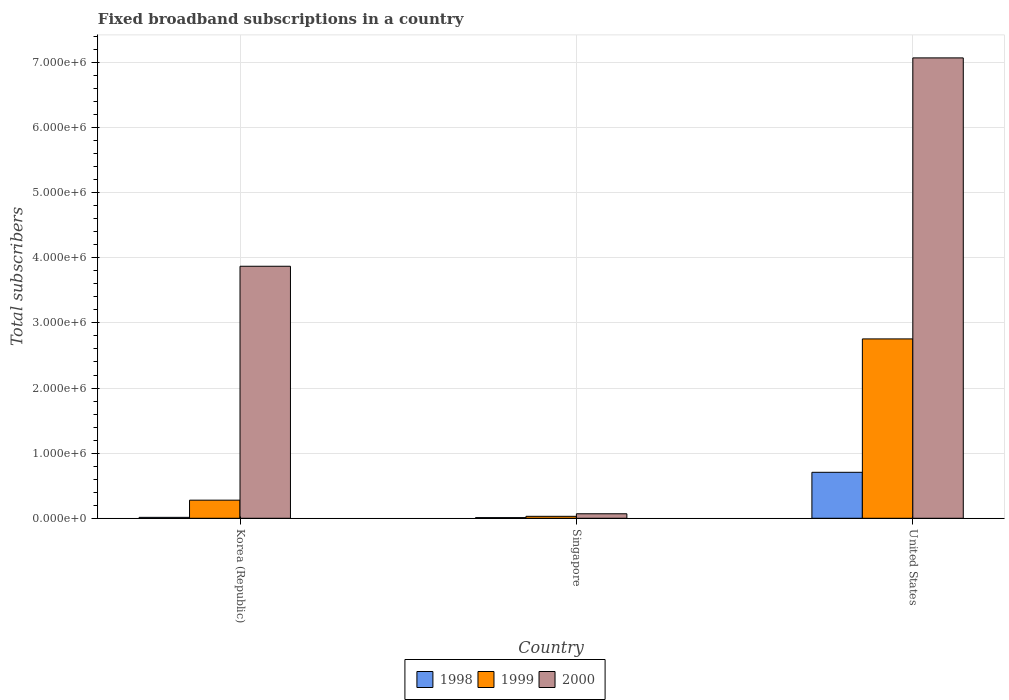How many groups of bars are there?
Offer a terse response. 3. Are the number of bars per tick equal to the number of legend labels?
Ensure brevity in your answer.  Yes. What is the label of the 2nd group of bars from the left?
Provide a short and direct response. Singapore. In how many cases, is the number of bars for a given country not equal to the number of legend labels?
Keep it short and to the point. 0. What is the number of broadband subscriptions in 2000 in United States?
Give a very brief answer. 7.07e+06. Across all countries, what is the maximum number of broadband subscriptions in 1998?
Your response must be concise. 7.06e+05. In which country was the number of broadband subscriptions in 1999 minimum?
Your response must be concise. Singapore. What is the total number of broadband subscriptions in 1998 in the graph?
Provide a short and direct response. 7.30e+05. What is the difference between the number of broadband subscriptions in 2000 in Korea (Republic) and that in United States?
Offer a very short reply. -3.20e+06. What is the difference between the number of broadband subscriptions in 2000 in Singapore and the number of broadband subscriptions in 1998 in United States?
Provide a succinct answer. -6.37e+05. What is the average number of broadband subscriptions in 1999 per country?
Make the answer very short. 1.02e+06. What is the difference between the number of broadband subscriptions of/in 2000 and number of broadband subscriptions of/in 1999 in Singapore?
Give a very brief answer. 3.90e+04. In how many countries, is the number of broadband subscriptions in 2000 greater than 7200000?
Keep it short and to the point. 0. What is the ratio of the number of broadband subscriptions in 1999 in Singapore to that in United States?
Your answer should be compact. 0.01. Is the number of broadband subscriptions in 1998 in Singapore less than that in United States?
Provide a succinct answer. Yes. What is the difference between the highest and the second highest number of broadband subscriptions in 1999?
Offer a terse response. 2.48e+05. What is the difference between the highest and the lowest number of broadband subscriptions in 2000?
Offer a terse response. 7.00e+06. In how many countries, is the number of broadband subscriptions in 2000 greater than the average number of broadband subscriptions in 2000 taken over all countries?
Provide a short and direct response. 2. How many bars are there?
Provide a short and direct response. 9. How many countries are there in the graph?
Your answer should be very brief. 3. Does the graph contain grids?
Keep it short and to the point. Yes. Where does the legend appear in the graph?
Make the answer very short. Bottom center. What is the title of the graph?
Offer a terse response. Fixed broadband subscriptions in a country. What is the label or title of the Y-axis?
Give a very brief answer. Total subscribers. What is the Total subscribers of 1998 in Korea (Republic)?
Keep it short and to the point. 1.40e+04. What is the Total subscribers of 1999 in Korea (Republic)?
Offer a very short reply. 2.78e+05. What is the Total subscribers in 2000 in Korea (Republic)?
Your answer should be compact. 3.87e+06. What is the Total subscribers in 1999 in Singapore?
Ensure brevity in your answer.  3.00e+04. What is the Total subscribers of 2000 in Singapore?
Make the answer very short. 6.90e+04. What is the Total subscribers of 1998 in United States?
Make the answer very short. 7.06e+05. What is the Total subscribers of 1999 in United States?
Ensure brevity in your answer.  2.75e+06. What is the Total subscribers in 2000 in United States?
Make the answer very short. 7.07e+06. Across all countries, what is the maximum Total subscribers of 1998?
Your answer should be compact. 7.06e+05. Across all countries, what is the maximum Total subscribers in 1999?
Offer a very short reply. 2.75e+06. Across all countries, what is the maximum Total subscribers in 2000?
Provide a succinct answer. 7.07e+06. Across all countries, what is the minimum Total subscribers of 2000?
Provide a succinct answer. 6.90e+04. What is the total Total subscribers of 1998 in the graph?
Offer a terse response. 7.30e+05. What is the total Total subscribers in 1999 in the graph?
Keep it short and to the point. 3.06e+06. What is the total Total subscribers in 2000 in the graph?
Ensure brevity in your answer.  1.10e+07. What is the difference between the Total subscribers in 1998 in Korea (Republic) and that in Singapore?
Provide a short and direct response. 4000. What is the difference between the Total subscribers in 1999 in Korea (Republic) and that in Singapore?
Your answer should be compact. 2.48e+05. What is the difference between the Total subscribers in 2000 in Korea (Republic) and that in Singapore?
Make the answer very short. 3.80e+06. What is the difference between the Total subscribers in 1998 in Korea (Republic) and that in United States?
Offer a very short reply. -6.92e+05. What is the difference between the Total subscribers in 1999 in Korea (Republic) and that in United States?
Offer a very short reply. -2.48e+06. What is the difference between the Total subscribers in 2000 in Korea (Republic) and that in United States?
Your answer should be very brief. -3.20e+06. What is the difference between the Total subscribers in 1998 in Singapore and that in United States?
Provide a succinct answer. -6.96e+05. What is the difference between the Total subscribers of 1999 in Singapore and that in United States?
Your response must be concise. -2.72e+06. What is the difference between the Total subscribers in 2000 in Singapore and that in United States?
Offer a very short reply. -7.00e+06. What is the difference between the Total subscribers in 1998 in Korea (Republic) and the Total subscribers in 1999 in Singapore?
Make the answer very short. -1.60e+04. What is the difference between the Total subscribers of 1998 in Korea (Republic) and the Total subscribers of 2000 in Singapore?
Keep it short and to the point. -5.50e+04. What is the difference between the Total subscribers of 1999 in Korea (Republic) and the Total subscribers of 2000 in Singapore?
Keep it short and to the point. 2.09e+05. What is the difference between the Total subscribers in 1998 in Korea (Republic) and the Total subscribers in 1999 in United States?
Ensure brevity in your answer.  -2.74e+06. What is the difference between the Total subscribers in 1998 in Korea (Republic) and the Total subscribers in 2000 in United States?
Your answer should be very brief. -7.06e+06. What is the difference between the Total subscribers of 1999 in Korea (Republic) and the Total subscribers of 2000 in United States?
Provide a succinct answer. -6.79e+06. What is the difference between the Total subscribers of 1998 in Singapore and the Total subscribers of 1999 in United States?
Your response must be concise. -2.74e+06. What is the difference between the Total subscribers of 1998 in Singapore and the Total subscribers of 2000 in United States?
Make the answer very short. -7.06e+06. What is the difference between the Total subscribers of 1999 in Singapore and the Total subscribers of 2000 in United States?
Your response must be concise. -7.04e+06. What is the average Total subscribers in 1998 per country?
Provide a succinct answer. 2.43e+05. What is the average Total subscribers of 1999 per country?
Give a very brief answer. 1.02e+06. What is the average Total subscribers of 2000 per country?
Your answer should be very brief. 3.67e+06. What is the difference between the Total subscribers in 1998 and Total subscribers in 1999 in Korea (Republic)?
Keep it short and to the point. -2.64e+05. What is the difference between the Total subscribers of 1998 and Total subscribers of 2000 in Korea (Republic)?
Make the answer very short. -3.86e+06. What is the difference between the Total subscribers in 1999 and Total subscribers in 2000 in Korea (Republic)?
Offer a terse response. -3.59e+06. What is the difference between the Total subscribers in 1998 and Total subscribers in 2000 in Singapore?
Your response must be concise. -5.90e+04. What is the difference between the Total subscribers in 1999 and Total subscribers in 2000 in Singapore?
Your response must be concise. -3.90e+04. What is the difference between the Total subscribers of 1998 and Total subscribers of 1999 in United States?
Your response must be concise. -2.05e+06. What is the difference between the Total subscribers in 1998 and Total subscribers in 2000 in United States?
Ensure brevity in your answer.  -6.36e+06. What is the difference between the Total subscribers of 1999 and Total subscribers of 2000 in United States?
Your answer should be compact. -4.32e+06. What is the ratio of the Total subscribers in 1999 in Korea (Republic) to that in Singapore?
Ensure brevity in your answer.  9.27. What is the ratio of the Total subscribers in 2000 in Korea (Republic) to that in Singapore?
Offer a very short reply. 56.09. What is the ratio of the Total subscribers in 1998 in Korea (Republic) to that in United States?
Offer a terse response. 0.02. What is the ratio of the Total subscribers of 1999 in Korea (Republic) to that in United States?
Your answer should be compact. 0.1. What is the ratio of the Total subscribers of 2000 in Korea (Republic) to that in United States?
Your response must be concise. 0.55. What is the ratio of the Total subscribers of 1998 in Singapore to that in United States?
Your answer should be compact. 0.01. What is the ratio of the Total subscribers of 1999 in Singapore to that in United States?
Your answer should be compact. 0.01. What is the ratio of the Total subscribers in 2000 in Singapore to that in United States?
Offer a very short reply. 0.01. What is the difference between the highest and the second highest Total subscribers of 1998?
Provide a short and direct response. 6.92e+05. What is the difference between the highest and the second highest Total subscribers of 1999?
Your response must be concise. 2.48e+06. What is the difference between the highest and the second highest Total subscribers of 2000?
Offer a terse response. 3.20e+06. What is the difference between the highest and the lowest Total subscribers of 1998?
Your response must be concise. 6.96e+05. What is the difference between the highest and the lowest Total subscribers of 1999?
Keep it short and to the point. 2.72e+06. What is the difference between the highest and the lowest Total subscribers in 2000?
Ensure brevity in your answer.  7.00e+06. 